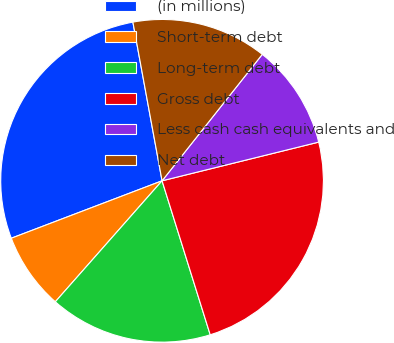Convert chart. <chart><loc_0><loc_0><loc_500><loc_500><pie_chart><fcel>(in millions)<fcel>Short-term debt<fcel>Long-term debt<fcel>Gross debt<fcel>Less cash cash equivalents and<fcel>Net debt<nl><fcel>27.9%<fcel>7.7%<fcel>16.33%<fcel>24.03%<fcel>10.48%<fcel>13.56%<nl></chart> 